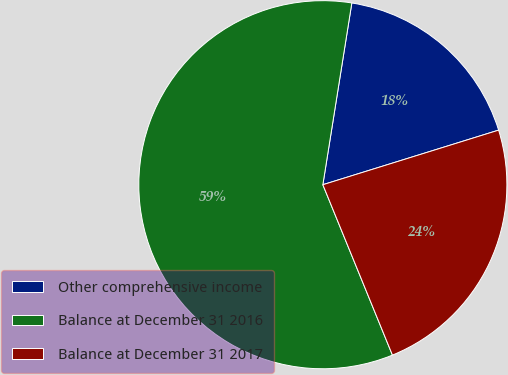Convert chart to OTSL. <chart><loc_0><loc_0><loc_500><loc_500><pie_chart><fcel>Other comprehensive income<fcel>Balance at December 31 2016<fcel>Balance at December 31 2017<nl><fcel>17.69%<fcel>58.69%<fcel>23.62%<nl></chart> 